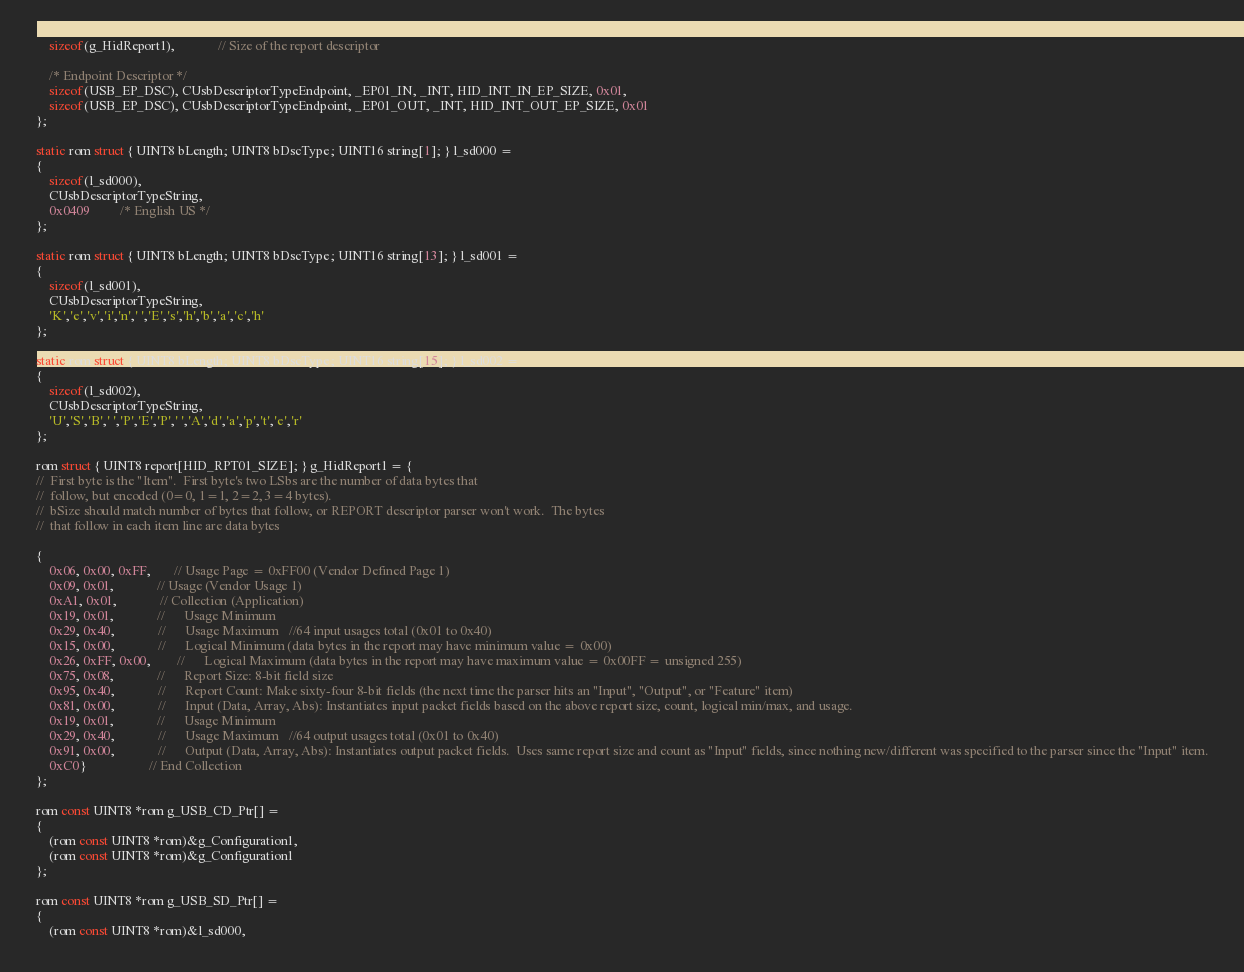<code> <loc_0><loc_0><loc_500><loc_500><_C_>    sizeof(g_HidReport1),             // Size of the report descriptor

    /* Endpoint Descriptor */
    sizeof(USB_EP_DSC), CUsbDescriptorTypeEndpoint, _EP01_IN, _INT, HID_INT_IN_EP_SIZE, 0x01,
    sizeof(USB_EP_DSC), CUsbDescriptorTypeEndpoint, _EP01_OUT, _INT, HID_INT_OUT_EP_SIZE, 0x01
};

static rom struct { UINT8 bLength; UINT8 bDscType; UINT16 string[1]; } l_sd000 = 
{
    sizeof(l_sd000),
    CUsbDescriptorTypeString,
    0x0409         /* English US */
};

static rom struct { UINT8 bLength; UINT8 bDscType; UINT16 string[13]; } l_sd001 = 
{
    sizeof(l_sd001),
    CUsbDescriptorTypeString,
    'K','e','v','i','n',' ','E','s','h','b','a','c','h'
};

static rom struct { UINT8 bLength; UINT8 bDscType; UINT16 string[15]; } l_sd002 = 
{
    sizeof(l_sd002),
    CUsbDescriptorTypeString,
    'U','S','B',' ','P','E','P',' ','A','d','a','p','t','e','r'
};

rom struct { UINT8 report[HID_RPT01_SIZE]; } g_HidReport1 = {
//	First byte is the "Item".  First byte's two LSbs are the number of data bytes that
//  follow, but encoded (0=0, 1=1, 2=2, 3=4 bytes).
//  bSize should match number of bytes that follow, or REPORT descriptor parser won't work.  The bytes
//  that follow in each item line are data bytes

{
    0x06, 0x00, 0xFF,       // Usage Page = 0xFF00 (Vendor Defined Page 1)
    0x09, 0x01,             // Usage (Vendor Usage 1)
    0xA1, 0x01,             // Collection (Application)
    0x19, 0x01,             //      Usage Minimum 
    0x29, 0x40,             //      Usage Maximum 	//64 input usages total (0x01 to 0x40)
    0x15, 0x00,             //      Logical Minimum (data bytes in the report may have minimum value = 0x00)
    0x26, 0xFF, 0x00, 	  	//      Logical Maximum (data bytes in the report may have maximum value = 0x00FF = unsigned 255)
    0x75, 0x08,             //      Report Size: 8-bit field size
    0x95, 0x40,             //      Report Count: Make sixty-four 8-bit fields (the next time the parser hits an "Input", "Output", or "Feature" item)
    0x81, 0x00,             //      Input (Data, Array, Abs): Instantiates input packet fields based on the above report size, count, logical min/max, and usage.
    0x19, 0x01,             //      Usage Minimum 
    0x29, 0x40,             //      Usage Maximum 	//64 output usages total (0x01 to 0x40)
    0x91, 0x00,             //      Output (Data, Array, Abs): Instantiates output packet fields.  Uses same report size and count as "Input" fields, since nothing new/different was specified to the parser since the "Input" item.
    0xC0}                   // End Collection
};    

rom const UINT8 *rom g_USB_CD_Ptr[] =
{
    (rom const UINT8 *rom)&g_Configuration1,
    (rom const UINT8 *rom)&g_Configuration1
};

rom const UINT8 *rom g_USB_SD_Ptr[] =
{
    (rom const UINT8 *rom)&l_sd000,</code> 